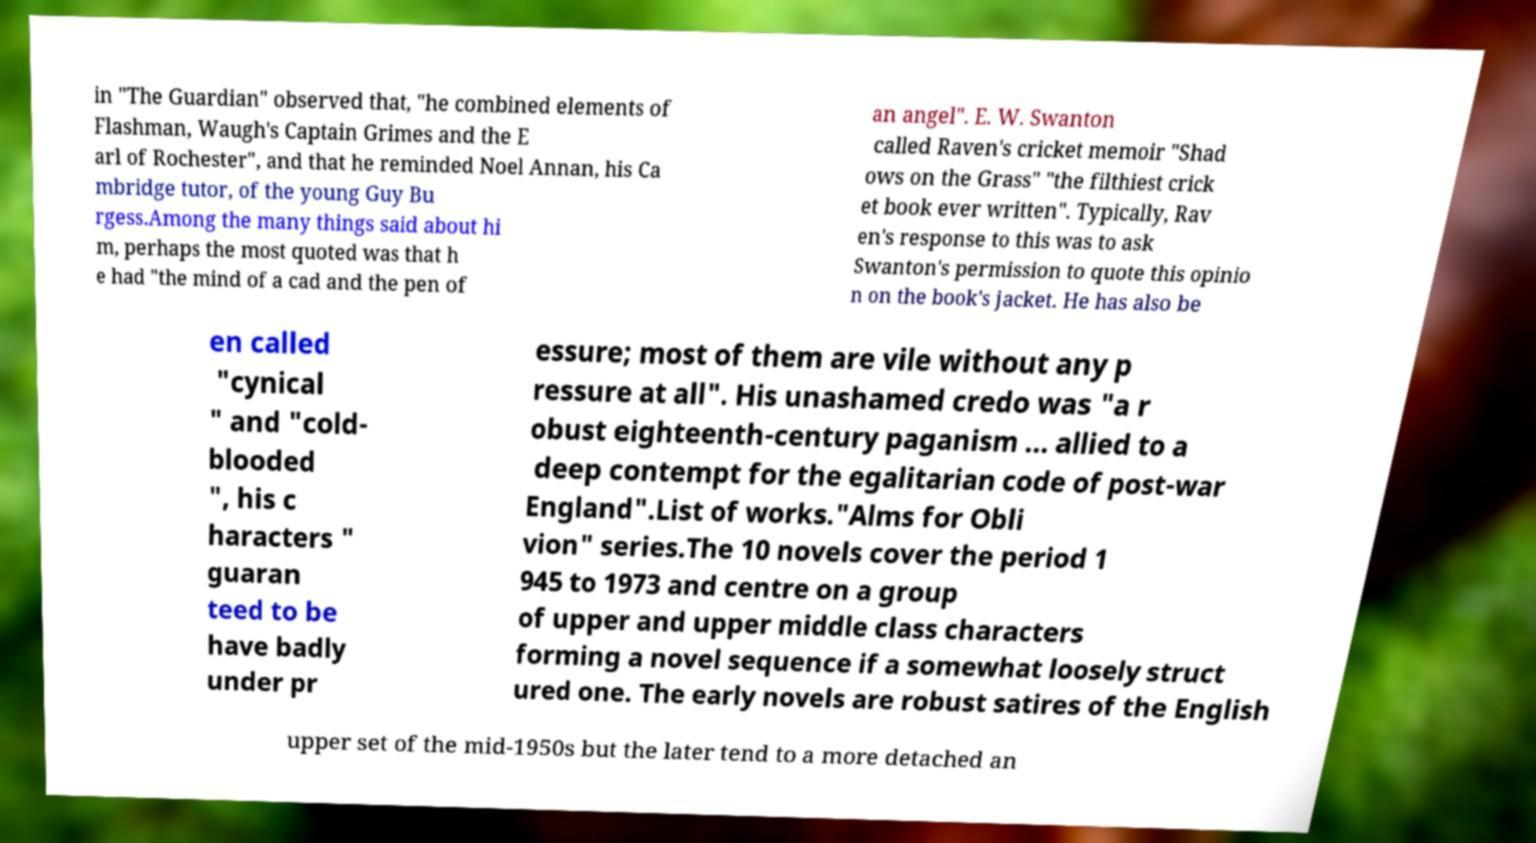What messages or text are displayed in this image? I need them in a readable, typed format. in "The Guardian" observed that, "he combined elements of Flashman, Waugh's Captain Grimes and the E arl of Rochester", and that he reminded Noel Annan, his Ca mbridge tutor, of the young Guy Bu rgess.Among the many things said about hi m, perhaps the most quoted was that h e had "the mind of a cad and the pen of an angel". E. W. Swanton called Raven's cricket memoir "Shad ows on the Grass" "the filthiest crick et book ever written". Typically, Rav en's response to this was to ask Swanton's permission to quote this opinio n on the book's jacket. He has also be en called "cynical " and "cold- blooded ", his c haracters " guaran teed to be have badly under pr essure; most of them are vile without any p ressure at all". His unashamed credo was "a r obust eighteenth-century paganism ... allied to a deep contempt for the egalitarian code of post-war England".List of works."Alms for Obli vion" series.The 10 novels cover the period 1 945 to 1973 and centre on a group of upper and upper middle class characters forming a novel sequence if a somewhat loosely struct ured one. The early novels are robust satires of the English upper set of the mid-1950s but the later tend to a more detached an 